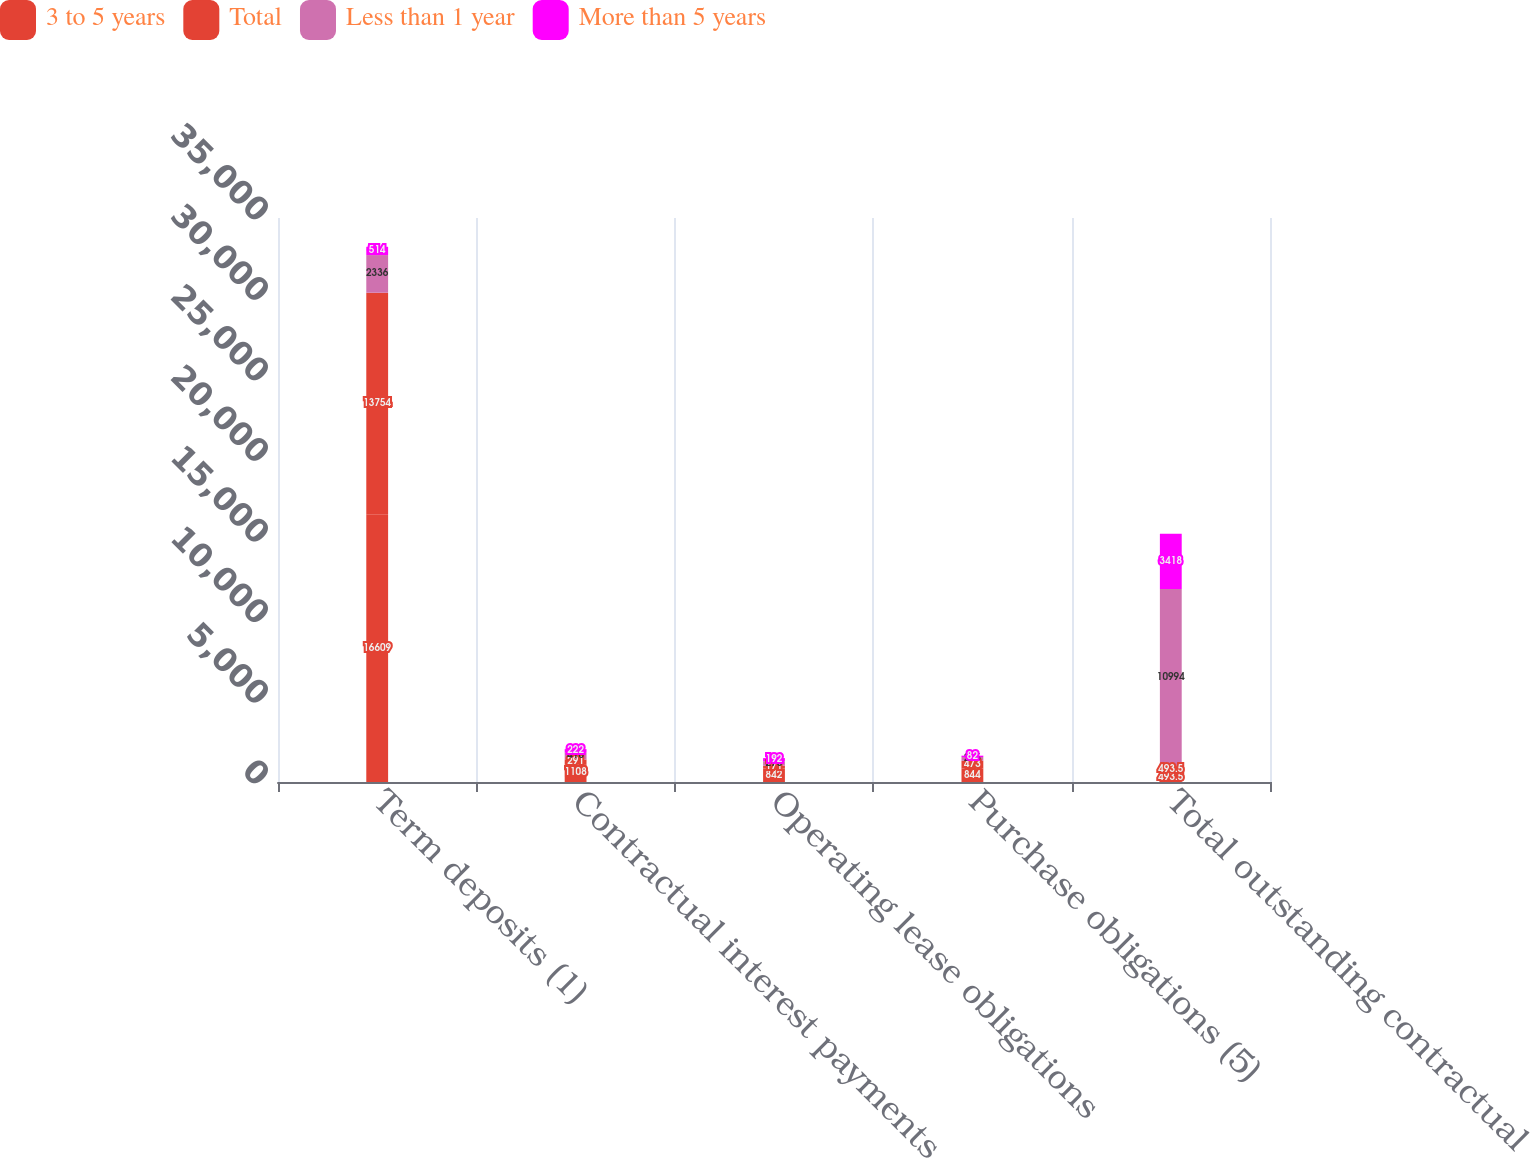Convert chart to OTSL. <chart><loc_0><loc_0><loc_500><loc_500><stacked_bar_chart><ecel><fcel>Term deposits (1)<fcel>Contractual interest payments<fcel>Operating lease obligations<fcel>Purchase obligations (5)<fcel>Total outstanding contractual<nl><fcel>3 to 5 years<fcel>16609<fcel>1108<fcel>842<fcel>844<fcel>493.5<nl><fcel>Total<fcel>13754<fcel>291<fcel>171<fcel>473<fcel>493.5<nl><fcel>Less than 1 year<fcel>2336<fcel>418<fcel>278<fcel>235<fcel>10994<nl><fcel>More than 5 years<fcel>514<fcel>222<fcel>192<fcel>82<fcel>3418<nl></chart> 